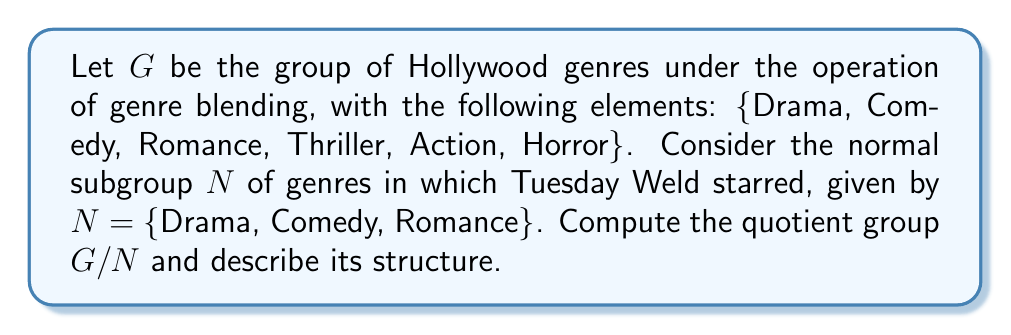Teach me how to tackle this problem. To compute the quotient group $G/N$, we need to follow these steps:

1) First, let's identify the cosets of $N$ in $G$:

   $N = \{Drama, Comedy, Romance\}$
   $Thriller + N = \{Thriller, Thriller+Drama, Thriller+Comedy, Thriller+Romance\}$
   $Action + N = \{Action, Action+Drama, Action+Comedy, Action+Romance\}$
   $Horror + N = \{Horror, Horror+Drama, Horror+Comedy, Horror+Romance\}$

2) These cosets form the elements of the quotient group $G/N$. Let's denote them as:

   $[N], [Thriller], [Action], [Horror]$

3) The order of $G/N$ is $|G/N| = |G|/|N| = 6/3 = 2$, which confirms we have the correct number of cosets.

4) To determine the structure of $G/N$, we need to consider the operation inherited from $G$. The operation in $G/N$ is defined as:

   $[a][b] = [ab]$ for any $a,b \in G$

5) We can see that:
   - $[N]$ acts as the identity element
   - $[Thriller][Thriller] = [N]$
   - $[Action][Action] = [N]$
   - $[Horror][Horror] = [N]$

6) This structure is isomorphic to the Klein four-group $V_4$, which is the direct product of two cyclic groups of order 2:

   $G/N \cong C_2 \times C_2$

Thus, the quotient group $G/N$ has the structure of the Klein four-group.
Answer: The quotient group $G/N$ is isomorphic to the Klein four-group $V_4 \cong C_2 \times C_2$, with elements $\{[N], [Thriller], [Action], [Horror]\}$. 